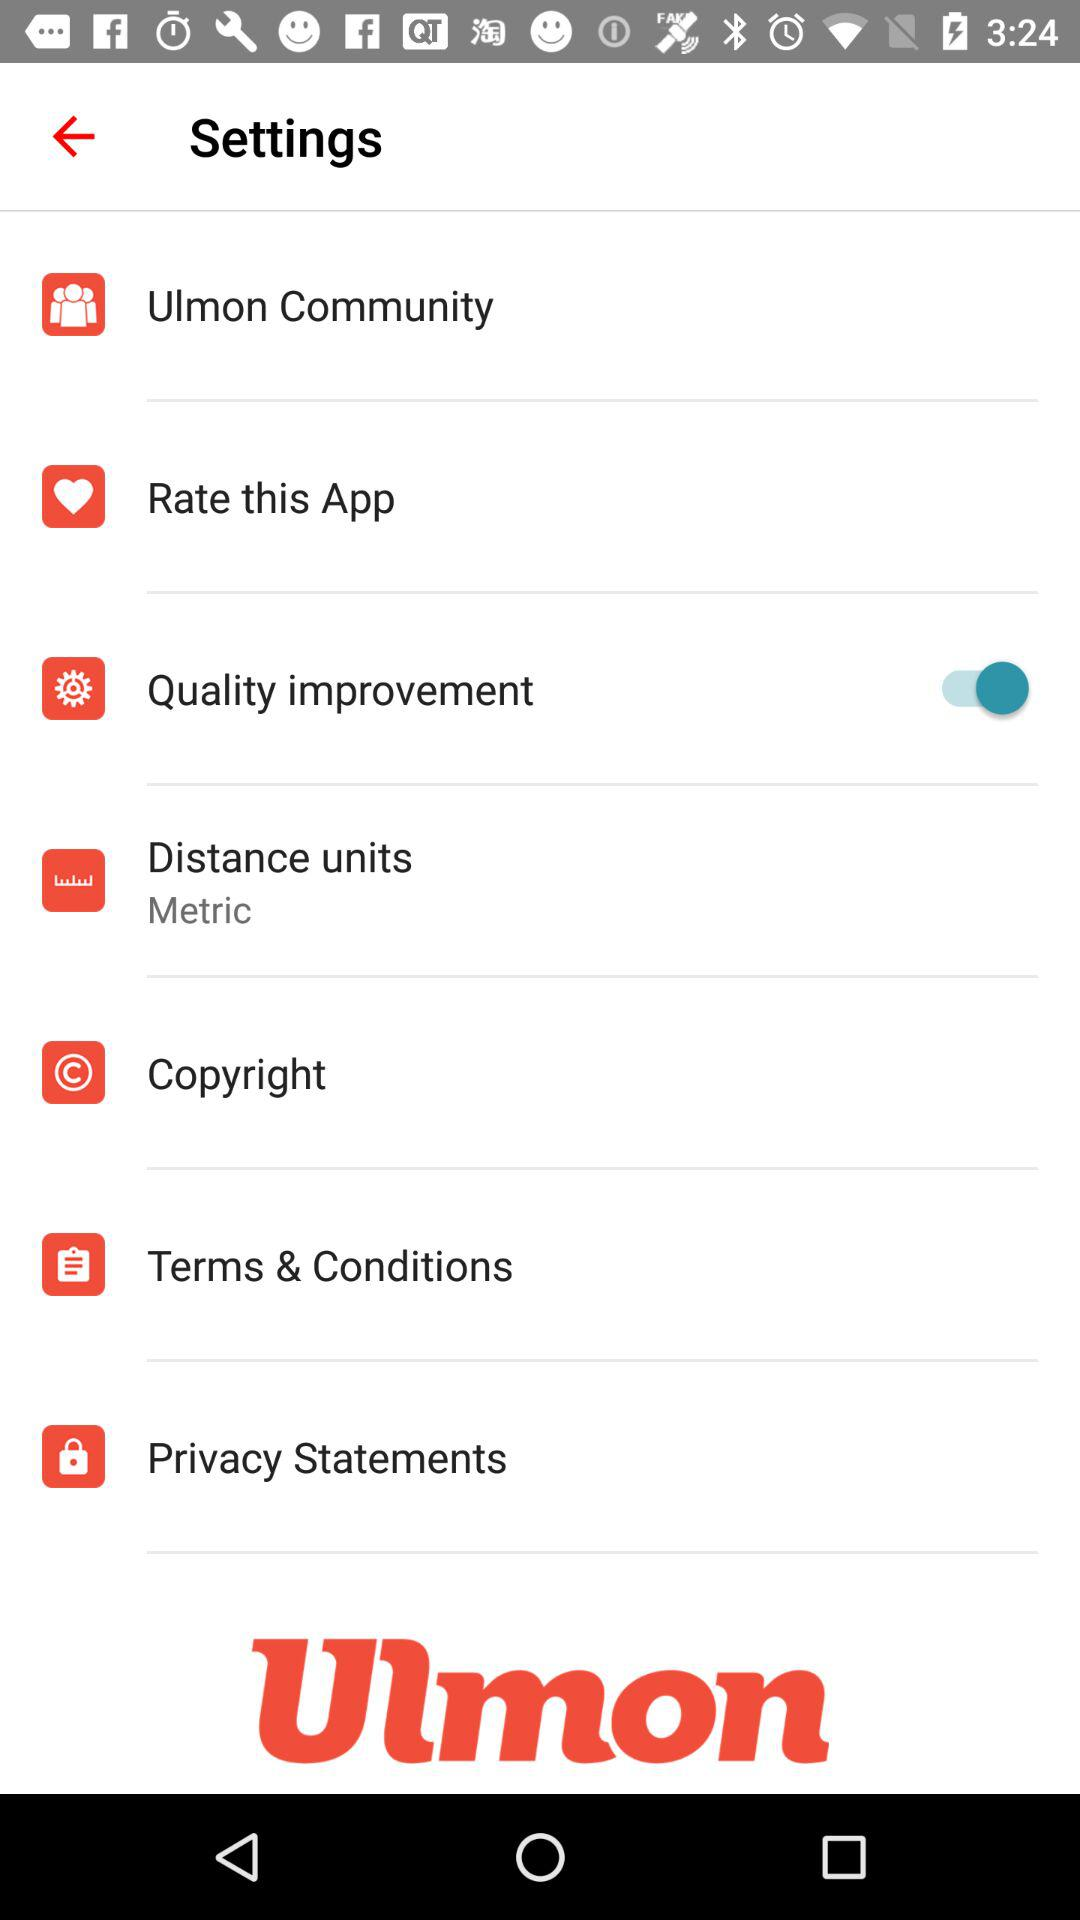What is the distance unit? The distance unit is "Metric". 